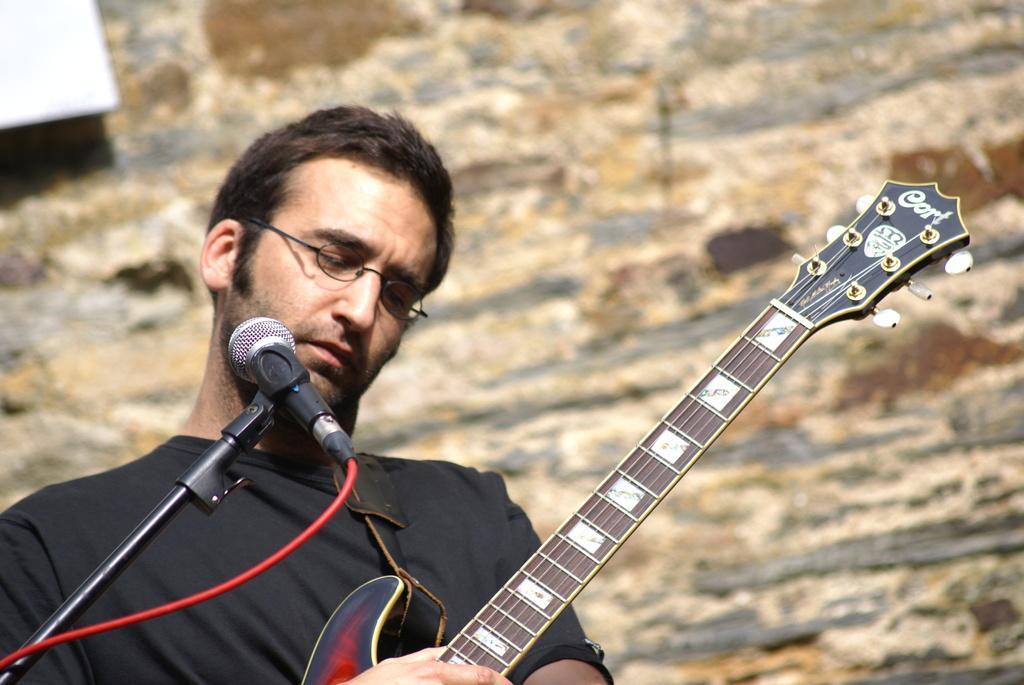Describe this image in one or two sentences. In this picture there is a man who is standing at the left side of the image by holding the guitar in his hands and there is a mic in front of him. 